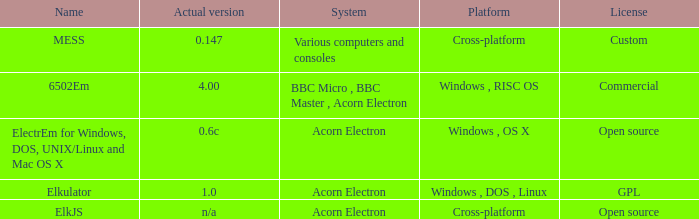What is the system called that is named ELKJS? Acorn Electron. 